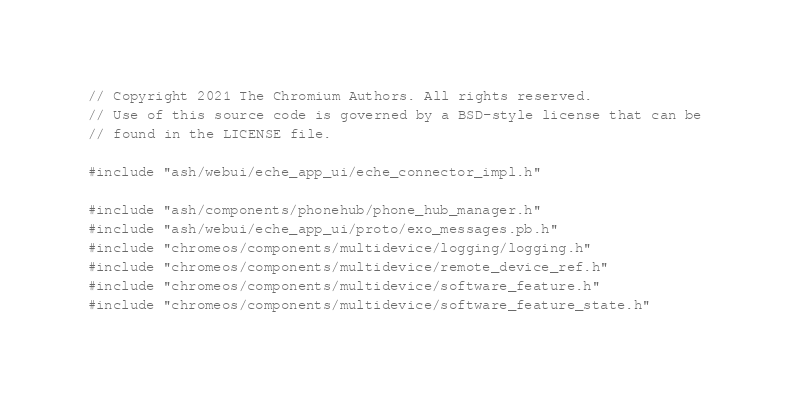Convert code to text. <code><loc_0><loc_0><loc_500><loc_500><_C++_>// Copyright 2021 The Chromium Authors. All rights reserved.
// Use of this source code is governed by a BSD-style license that can be
// found in the LICENSE file.

#include "ash/webui/eche_app_ui/eche_connector_impl.h"

#include "ash/components/phonehub/phone_hub_manager.h"
#include "ash/webui/eche_app_ui/proto/exo_messages.pb.h"
#include "chromeos/components/multidevice/logging/logging.h"
#include "chromeos/components/multidevice/remote_device_ref.h"
#include "chromeos/components/multidevice/software_feature.h"
#include "chromeos/components/multidevice/software_feature_state.h"</code> 